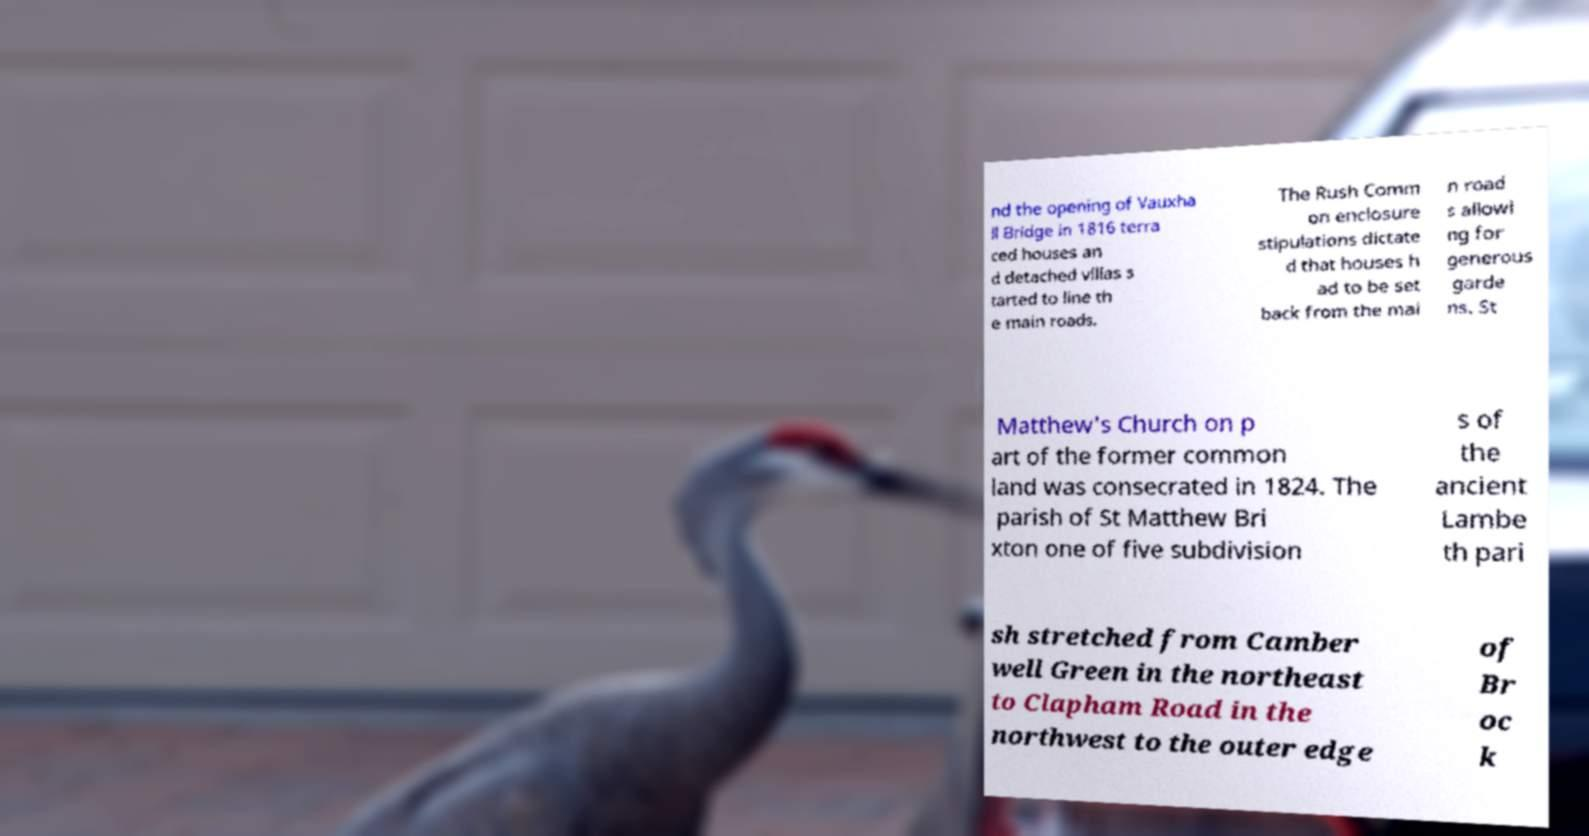There's text embedded in this image that I need extracted. Can you transcribe it verbatim? nd the opening of Vauxha ll Bridge in 1816 terra ced houses an d detached villas s tarted to line th e main roads. The Rush Comm on enclosure stipulations dictate d that houses h ad to be set back from the mai n road s allowi ng for generous garde ns. St Matthew's Church on p art of the former common land was consecrated in 1824. The parish of St Matthew Bri xton one of five subdivision s of the ancient Lambe th pari sh stretched from Camber well Green in the northeast to Clapham Road in the northwest to the outer edge of Br oc k 